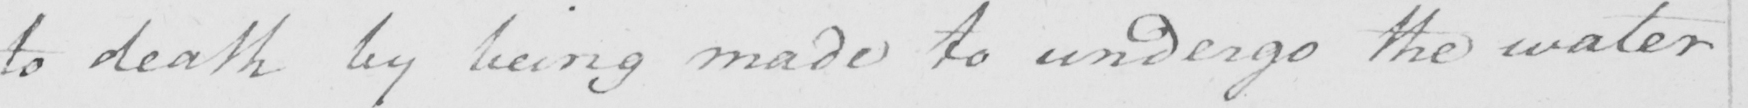Please transcribe the handwritten text in this image. to death by being made to undergo the water 